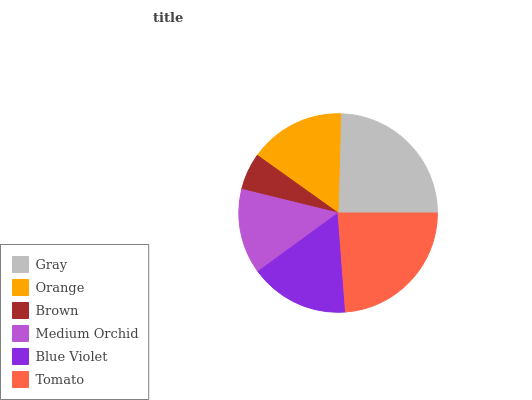Is Brown the minimum?
Answer yes or no. Yes. Is Gray the maximum?
Answer yes or no. Yes. Is Orange the minimum?
Answer yes or no. No. Is Orange the maximum?
Answer yes or no. No. Is Gray greater than Orange?
Answer yes or no. Yes. Is Orange less than Gray?
Answer yes or no. Yes. Is Orange greater than Gray?
Answer yes or no. No. Is Gray less than Orange?
Answer yes or no. No. Is Blue Violet the high median?
Answer yes or no. Yes. Is Orange the low median?
Answer yes or no. Yes. Is Brown the high median?
Answer yes or no. No. Is Brown the low median?
Answer yes or no. No. 